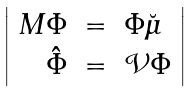<formula> <loc_0><loc_0><loc_500><loc_500>\left | \begin{array} { r c l } M \Phi & = & \Phi \breve { \mu } \\ \hat { \Phi } & = & { \mathcal { V } } \Phi \end{array} \right |</formula> 